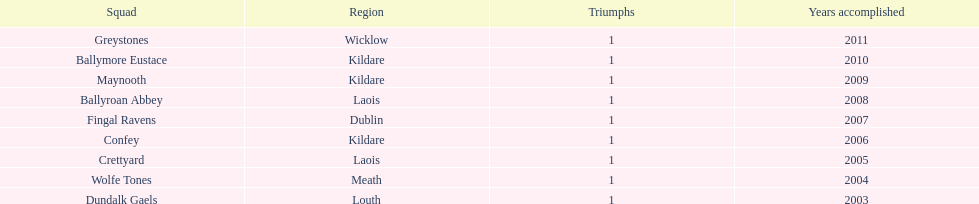Could you help me parse every detail presented in this table? {'header': ['Squad', 'Region', 'Triumphs', 'Years accomplished'], 'rows': [['Greystones', 'Wicklow', '1', '2011'], ['Ballymore Eustace', 'Kildare', '1', '2010'], ['Maynooth', 'Kildare', '1', '2009'], ['Ballyroan Abbey', 'Laois', '1', '2008'], ['Fingal Ravens', 'Dublin', '1', '2007'], ['Confey', 'Kildare', '1', '2006'], ['Crettyard', 'Laois', '1', '2005'], ['Wolfe Tones', 'Meath', '1', '2004'], ['Dundalk Gaels', 'Louth', '1', '2003']]} Which team won previous to crettyard? Wolfe Tones. 